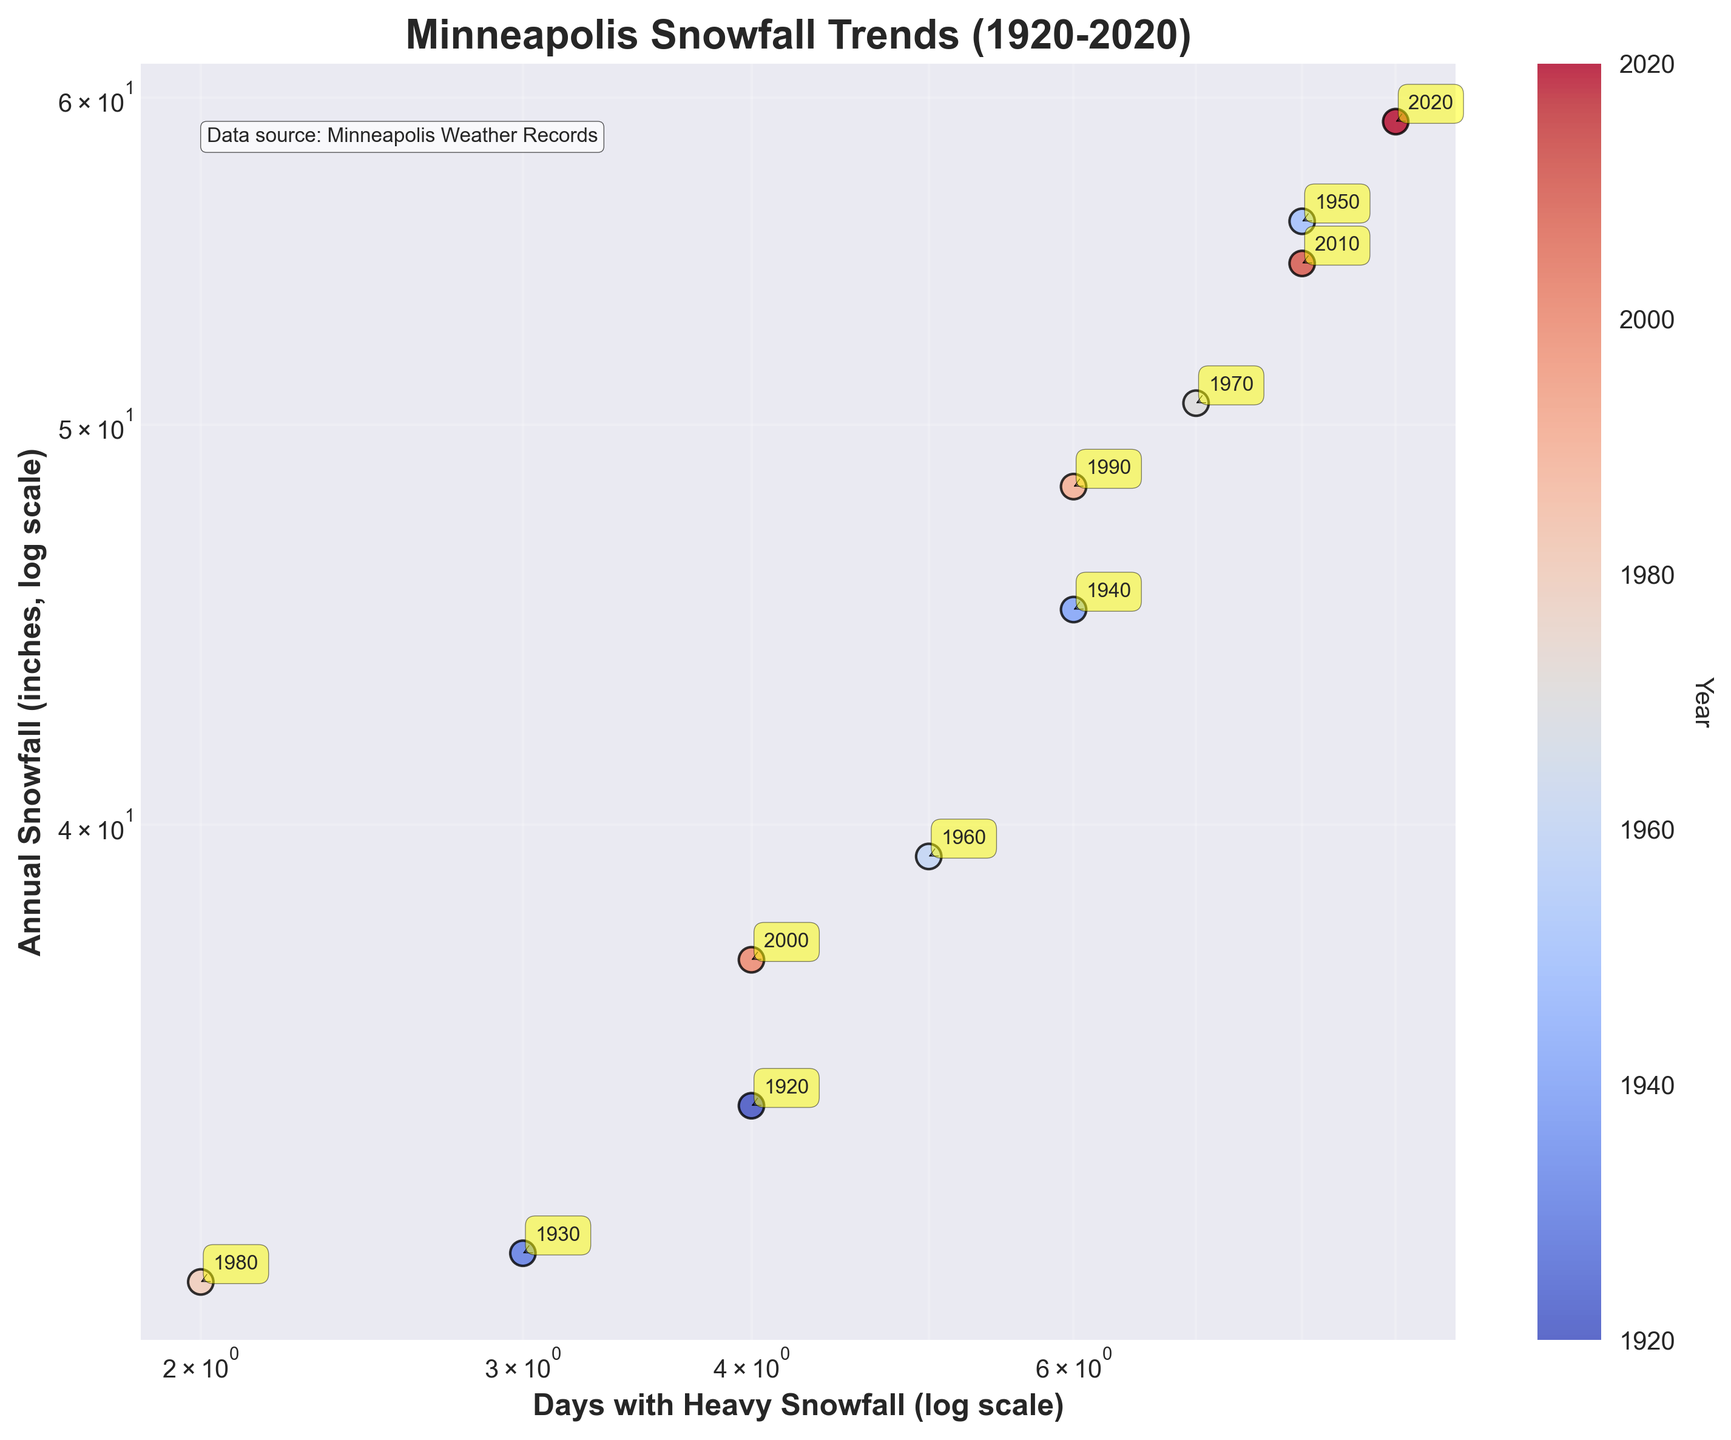What is the title of the scatter plot? The title is typically displayed prominently at the top of the plot. In this case, the title is "Minneapolis Snowfall Trends (1920-2020)" as indicated in the code provided.
Answer: Minneapolis Snowfall Trends (1920-2020) How many days with heavy snowfall occurred in 2020? Each data point represents a specific year with coordinates for days of heavy snowfall and annual snowfall inches. The data point for 2020 shows 9 days of heavy snowfall.
Answer: 9 Which year had the lowest annual snowfall? By examining the y-axis (annual snowfall inches) and identifying the lowest data point, the year marked as 1980 shows the smallest snowfall amount of 31 inches.
Answer: 1980 What is the relationship between the number of days with heavy snowfall and annual snowfall accumulation in the given data? Generally, there is a trend where an increase in the number of days with heavy snowfall corresponds to an increase in annual snowfall accumulation. This observation is evident from the upward slope of data points in the scatter plot.
Answer: Positive relationship What is the difference in the number of days with heavy snowfall between 1930 and 2010? Find the x-values (days of heavy snowfall) for both years: 3 days for 1930 and 8 days for 2010. Subtract the former from the latter, i.e., 8 - 3 = 5 days.
Answer: 5 days Which year had the most significant annual snowfall accumulation, and what was the amount? The highest data point on the y-axis (annual snowfall inches) indicates 59.2 inches in 2020. This can be confirmed by checking the data.
Answer: 2020, 59.2 inches On average, how many days with heavy snowfall occurred in the 1940s and 1950s combined? Sum the days with heavy snowfall for the years in the 1940s and 1950s then divide by the number of years. In this case: (6 days in 1940 + 8 days in 1950) / 2 = 7 days average.
Answer: 7 days Compare the annual snowfall accumulations for the years 1980 and 1990. By looking at the y-axis values for these years, 1980 had 31 inches and 1990 had 48.3 inches. 1990 had more snowfall than 1980.
Answer: 1980: 31 inches, 1990: 48.3 inches What is the median value for the number of days with heavy snowfall across all years? First, list the days with heavy snowfall in ascending order: 2, 3, 4, 4, 5, 6, 6, 7, 8, 8, 9. The median is the middle value, which is 6.
Answer: 6 days 